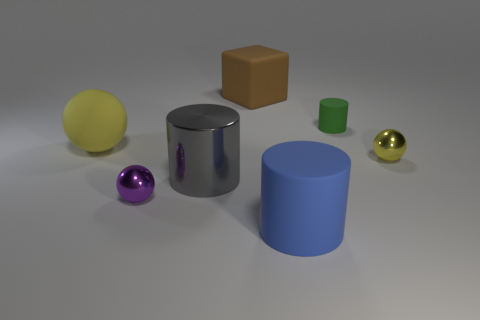The metallic thing that is the same color as the matte ball is what shape?
Provide a short and direct response. Sphere. The metallic object that is the same color as the big rubber ball is what size?
Offer a terse response. Small. Is the number of rubber cylinders behind the large gray object greater than the number of big brown rubber cylinders?
Your answer should be very brief. Yes. There is a metallic thing that is behind the purple thing and to the left of the big blue rubber object; what shape is it?
Your answer should be very brief. Cylinder. Does the brown thing have the same size as the yellow shiny object?
Give a very brief answer. No. There is a small green rubber cylinder; how many yellow shiny balls are behind it?
Your response must be concise. 0. Are there an equal number of green rubber things to the right of the purple object and large metal cylinders that are behind the gray shiny cylinder?
Ensure brevity in your answer.  No. There is a tiny metal thing left of the large blue thing; is it the same shape as the green object?
Give a very brief answer. No. Is there anything else that is made of the same material as the blue object?
Make the answer very short. Yes. Is the size of the green cylinder the same as the metallic thing to the right of the brown rubber object?
Give a very brief answer. Yes. 